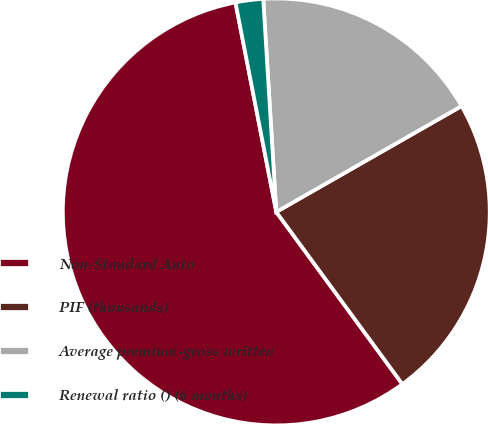Convert chart. <chart><loc_0><loc_0><loc_500><loc_500><pie_chart><fcel>Non-Standard Auto<fcel>PIF (thousands)<fcel>Average premium-gross written<fcel>Renewal ratio () (6 months)<nl><fcel>56.99%<fcel>23.2%<fcel>17.71%<fcel>2.09%<nl></chart> 